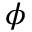<formula> <loc_0><loc_0><loc_500><loc_500>\phi</formula> 